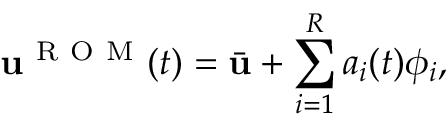Convert formula to latex. <formula><loc_0><loc_0><loc_500><loc_500>u ^ { R O M } ( t ) = \bar { u } + \sum _ { i = 1 } ^ { R } a _ { i } ( t ) \phi _ { i } ,</formula> 